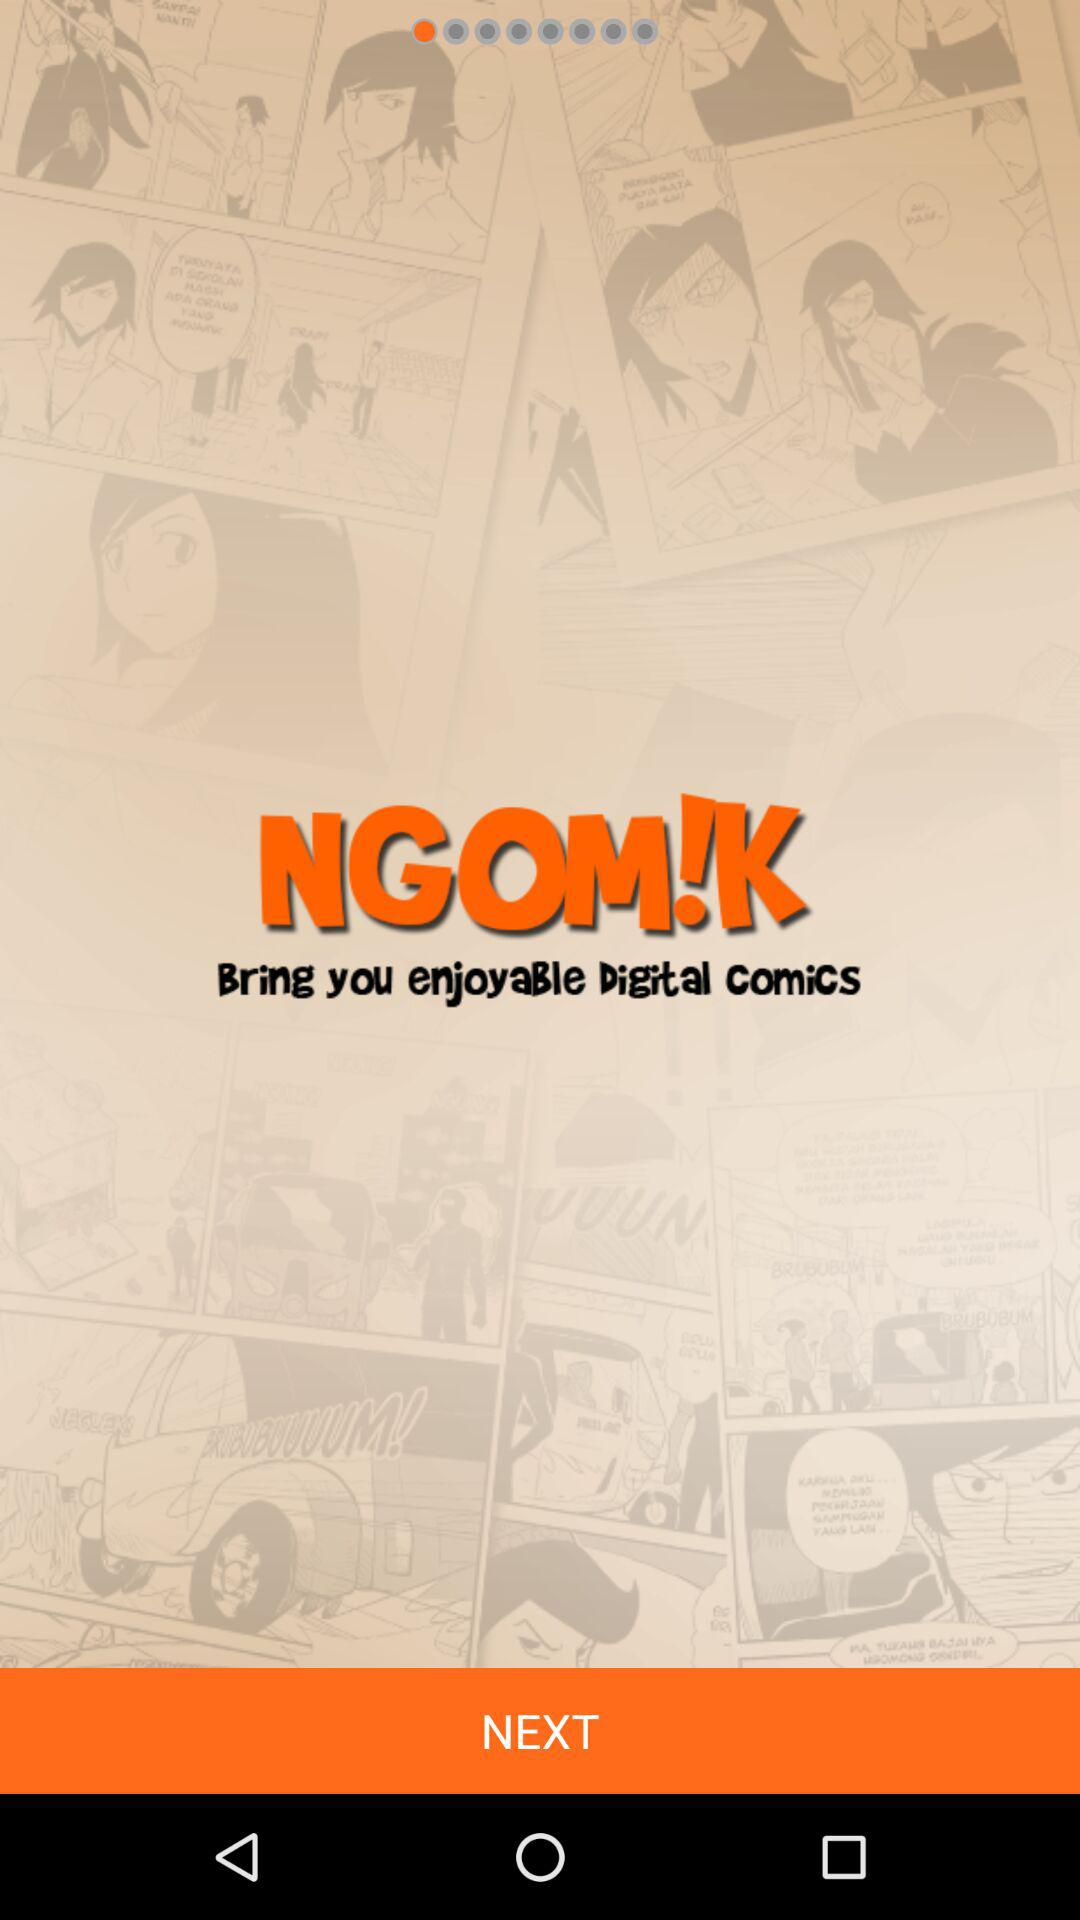What is the application name? The application name is "NGOM!K". 